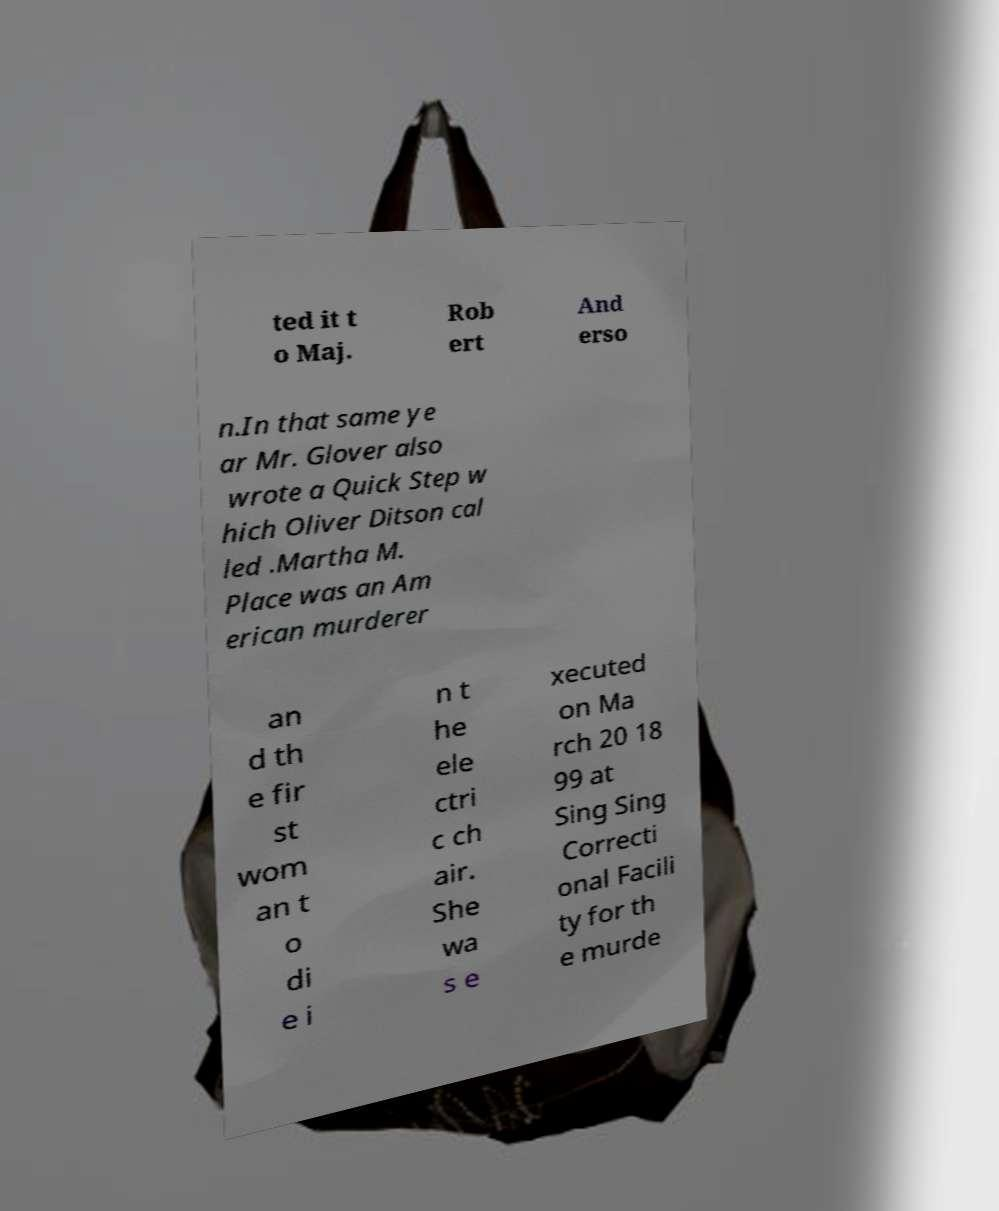Can you accurately transcribe the text from the provided image for me? ted it t o Maj. Rob ert And erso n.In that same ye ar Mr. Glover also wrote a Quick Step w hich Oliver Ditson cal led .Martha M. Place was an Am erican murderer an d th e fir st wom an t o di e i n t he ele ctri c ch air. She wa s e xecuted on Ma rch 20 18 99 at Sing Sing Correcti onal Facili ty for th e murde 